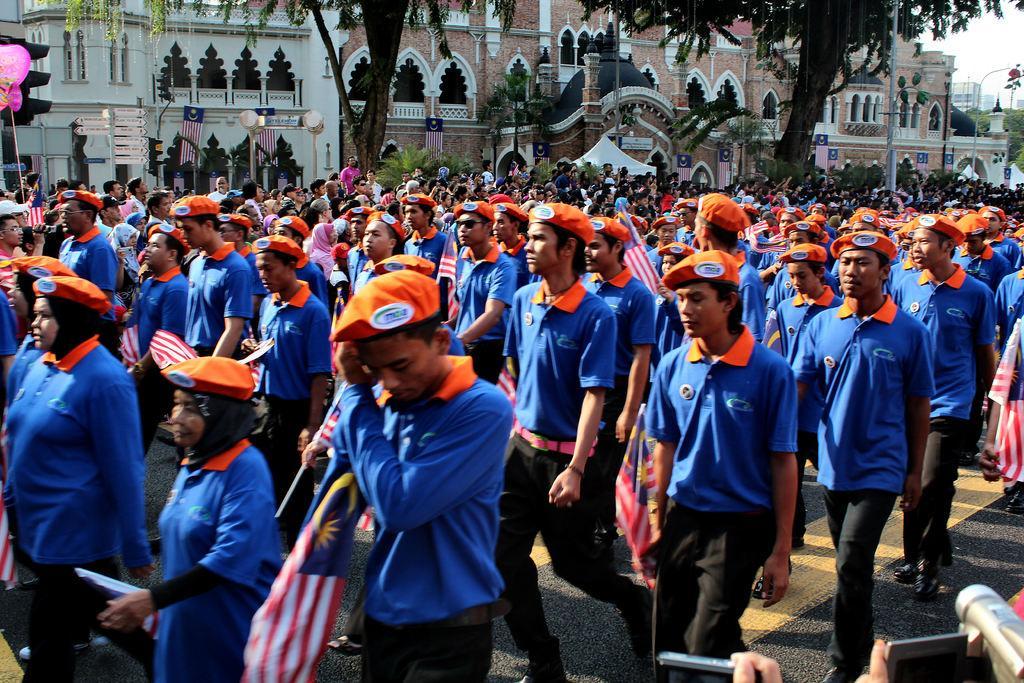In one or two sentences, can you explain what this image depicts? In this image I can see number of persons wearing blue, orange and black colored dresses are standing on the ground. I can see they are holding flags in their hands. I can see few trees, few buildings and the sky in the background. 